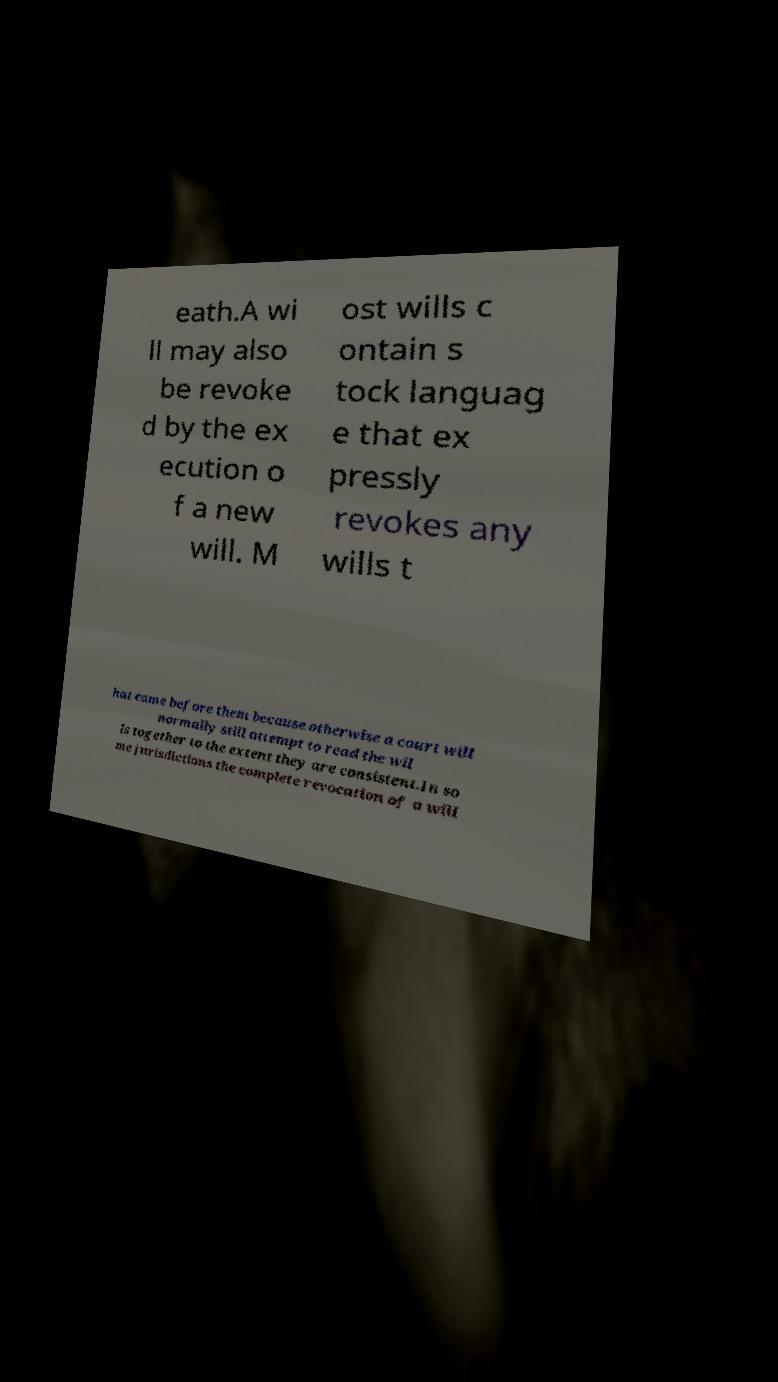Could you extract and type out the text from this image? eath.A wi ll may also be revoke d by the ex ecution o f a new will. M ost wills c ontain s tock languag e that ex pressly revokes any wills t hat came before them because otherwise a court will normally still attempt to read the wil ls together to the extent they are consistent.In so me jurisdictions the complete revocation of a will 